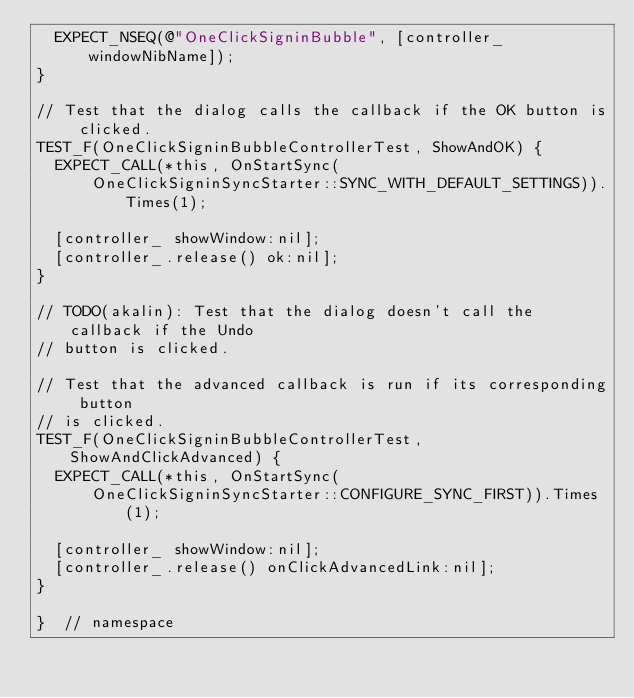Convert code to text. <code><loc_0><loc_0><loc_500><loc_500><_ObjectiveC_>  EXPECT_NSEQ(@"OneClickSigninBubble", [controller_ windowNibName]);
}

// Test that the dialog calls the callback if the OK button is clicked.
TEST_F(OneClickSigninBubbleControllerTest, ShowAndOK) {
  EXPECT_CALL(*this, OnStartSync(
      OneClickSigninSyncStarter::SYNC_WITH_DEFAULT_SETTINGS)).Times(1);

  [controller_ showWindow:nil];
  [controller_.release() ok:nil];
}

// TODO(akalin): Test that the dialog doesn't call the callback if the Undo
// button is clicked.

// Test that the advanced callback is run if its corresponding button
// is clicked.
TEST_F(OneClickSigninBubbleControllerTest, ShowAndClickAdvanced) {
  EXPECT_CALL(*this, OnStartSync(
      OneClickSigninSyncStarter::CONFIGURE_SYNC_FIRST)).Times(1);

  [controller_ showWindow:nil];
  [controller_.release() onClickAdvancedLink:nil];
}

}  // namespace
</code> 